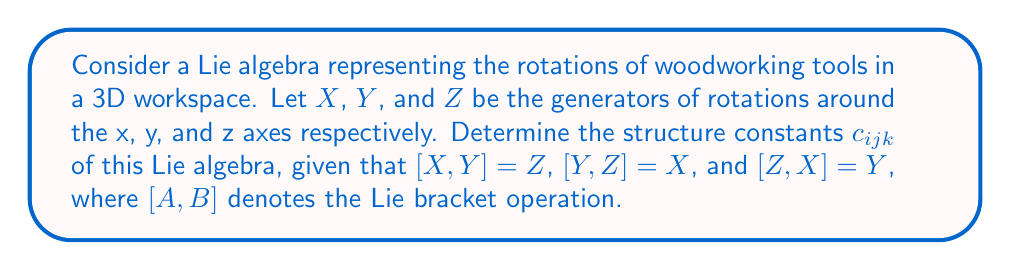Provide a solution to this math problem. To determine the structure constants of this Lie algebra, we need to follow these steps:

1) Recall that for a Lie algebra with basis elements $\{e_i\}$, the structure constants $c_{ijk}$ are defined by the equation:

   $$[e_i, e_j] = \sum_k c_{ijk} e_k$$

2) In our case, we have $e_1 = X$, $e_2 = Y$, and $e_3 = Z$. We need to express each Lie bracket in terms of these basis elements.

3) Given:
   $[X,Y] = Z$, which means $[e_1, e_2] = e_3$
   $[Y,Z] = X$, which means $[e_2, e_3] = e_1$
   $[Z,X] = Y$, which means $[e_3, e_1] = e_2$

4) Let's determine the non-zero structure constants:

   For $[X,Y] = Z$: $c_{123} = 1$
   For $[Y,Z] = X$: $c_{231} = 1$
   For $[Z,X] = Y$: $c_{312} = 1$

5) Note that the structure constants are antisymmetric in the first two indices:
   $c_{ijk} = -c_{jik}$

   Therefore:
   $c_{213} = -1$
   $c_{321} = -1$
   $c_{132} = -1$

6) All other structure constants are zero.

This Lie algebra is isomorphic to $\mathfrak{so}(3)$, the special orthogonal Lie algebra in 3 dimensions, which represents 3D rotations. This is particularly relevant for woodworking, as it describes the rotations of tools and workpieces in a 3D workshop space.
Answer: The non-zero structure constants are:
$c_{123} = c_{231} = c_{312} = 1$
$c_{213} = c_{321} = c_{132} = -1$
All other $c_{ijk} = 0$ 